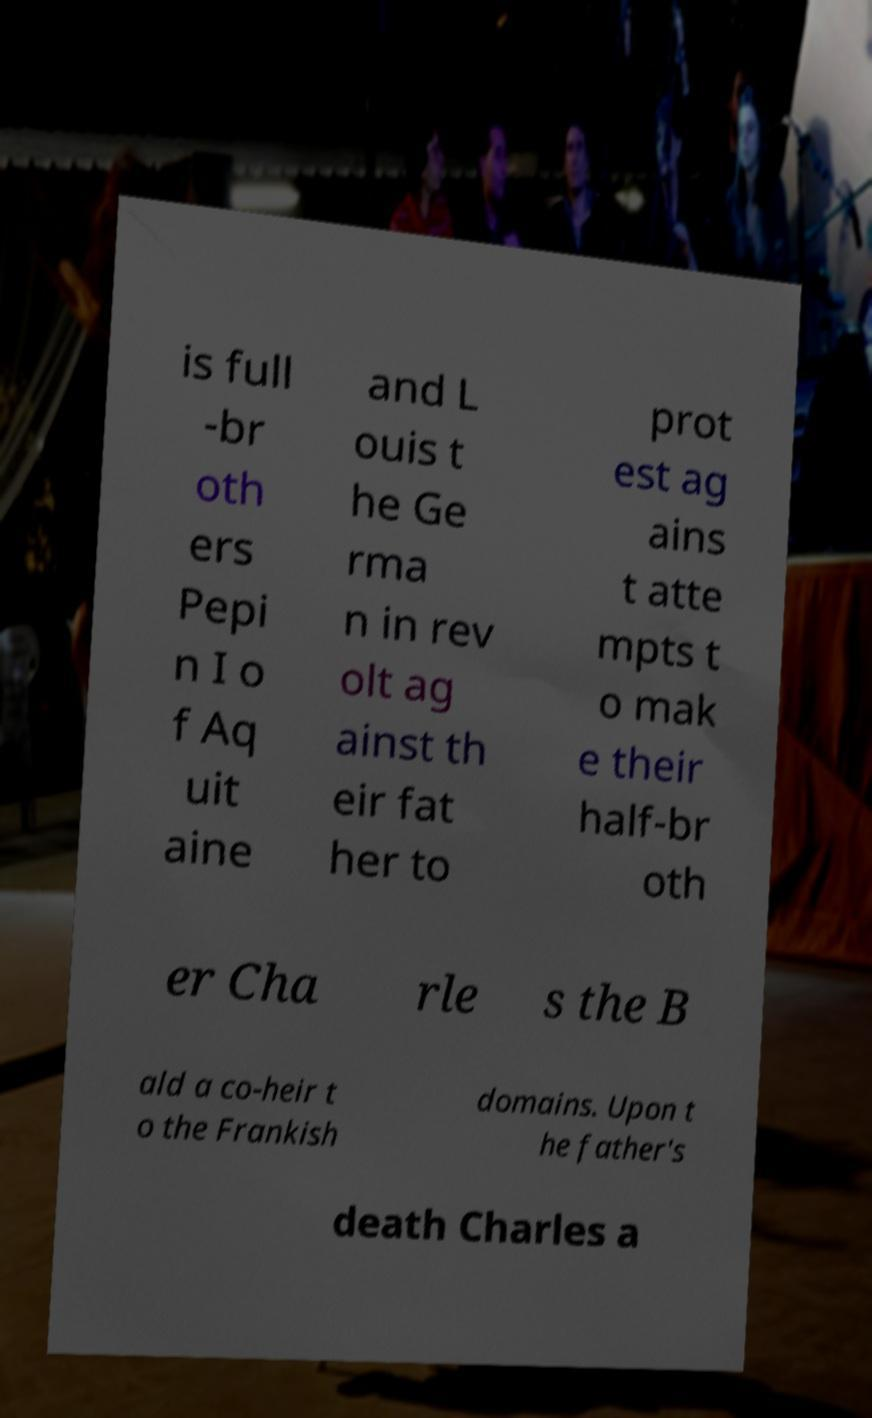There's text embedded in this image that I need extracted. Can you transcribe it verbatim? is full -br oth ers Pepi n I o f Aq uit aine and L ouis t he Ge rma n in rev olt ag ainst th eir fat her to prot est ag ains t atte mpts t o mak e their half-br oth er Cha rle s the B ald a co-heir t o the Frankish domains. Upon t he father's death Charles a 